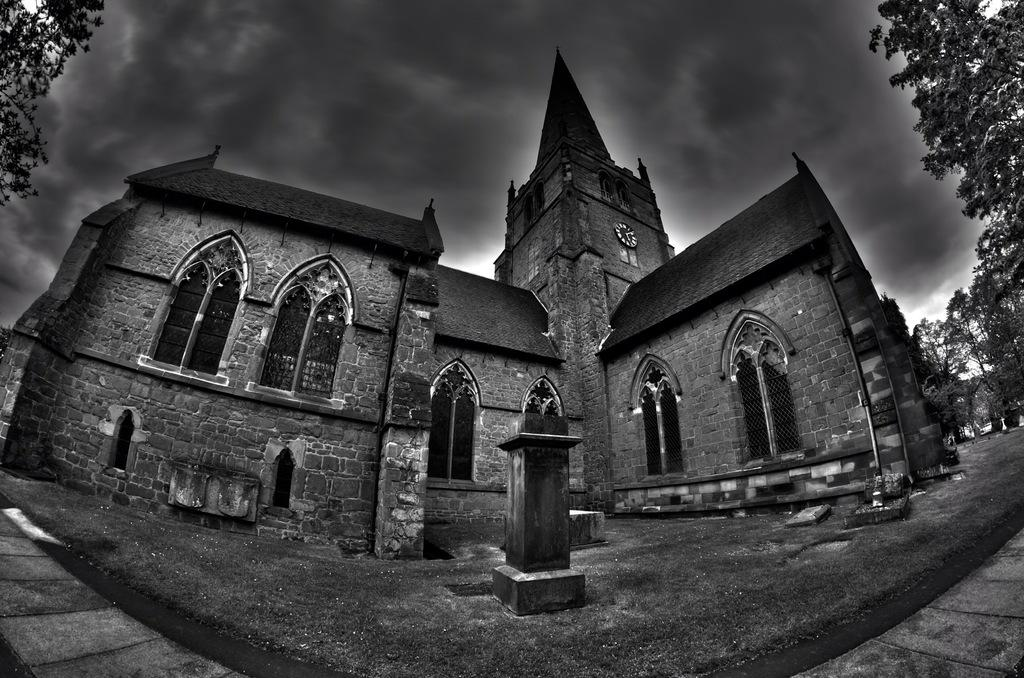What is the color scheme of the image? The image is black and white. What is the main subject in the image? There is a building in the image. What type of vegetation can be seen on both sides of the image? There are trees on the left side and the right side of the image. What is visible in the background of the image? The sky is visible in the background of the image. What can be observed in the sky? Clouds are present in the sky. What word is written on the building in the image? There is no word visible on the building in the image, as it is a black and white photograph. What story does the image tell about the building? The image does not tell a story about the building; it simply shows the building, trees, and sky. 